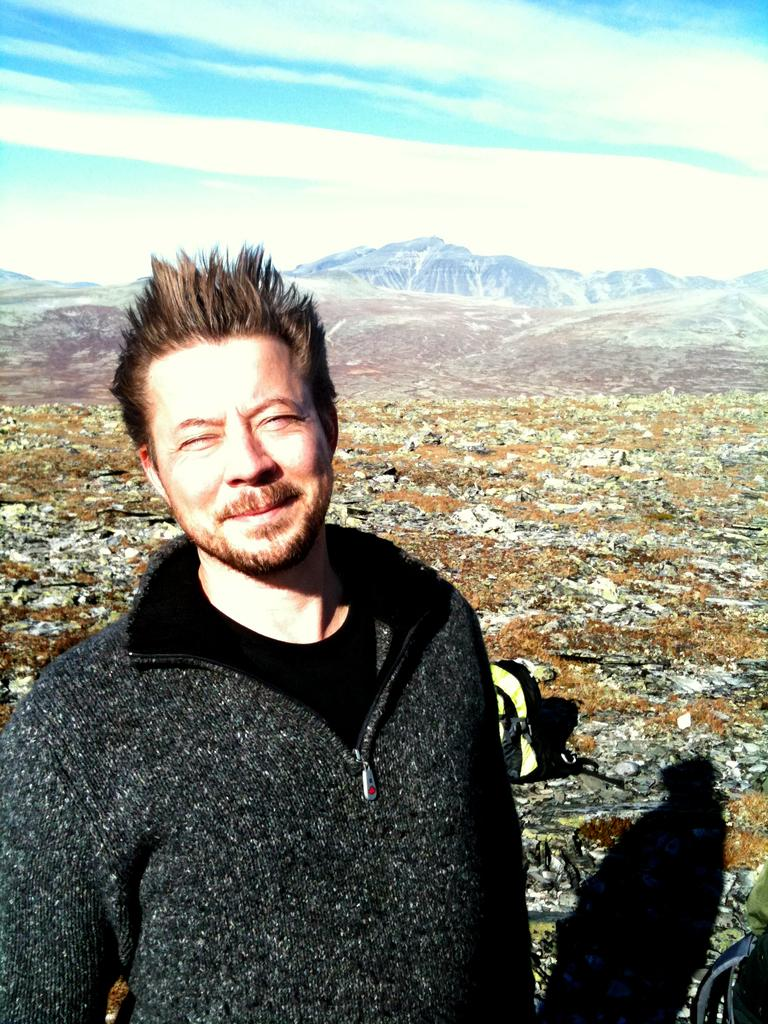What is the main subject of the image? There is a man standing in the image. What can be seen in the background of the image? Hills and the sky are visible in the background of the image. What type of plantation can be seen in the image? There is no plantation present in the image; it features a man standing in front of hills and the sky. How does the man's breath appear in the image? There is no indication of the man's breath in the image, as it is a still photograph. 